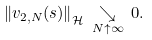Convert formula to latex. <formula><loc_0><loc_0><loc_500><loc_500>\left \| v _ { 2 , N } ( s ) \right \| _ { \mathcal { H } } \, \underset { N \uparrow \infty } { \searrow } \, 0 .</formula> 